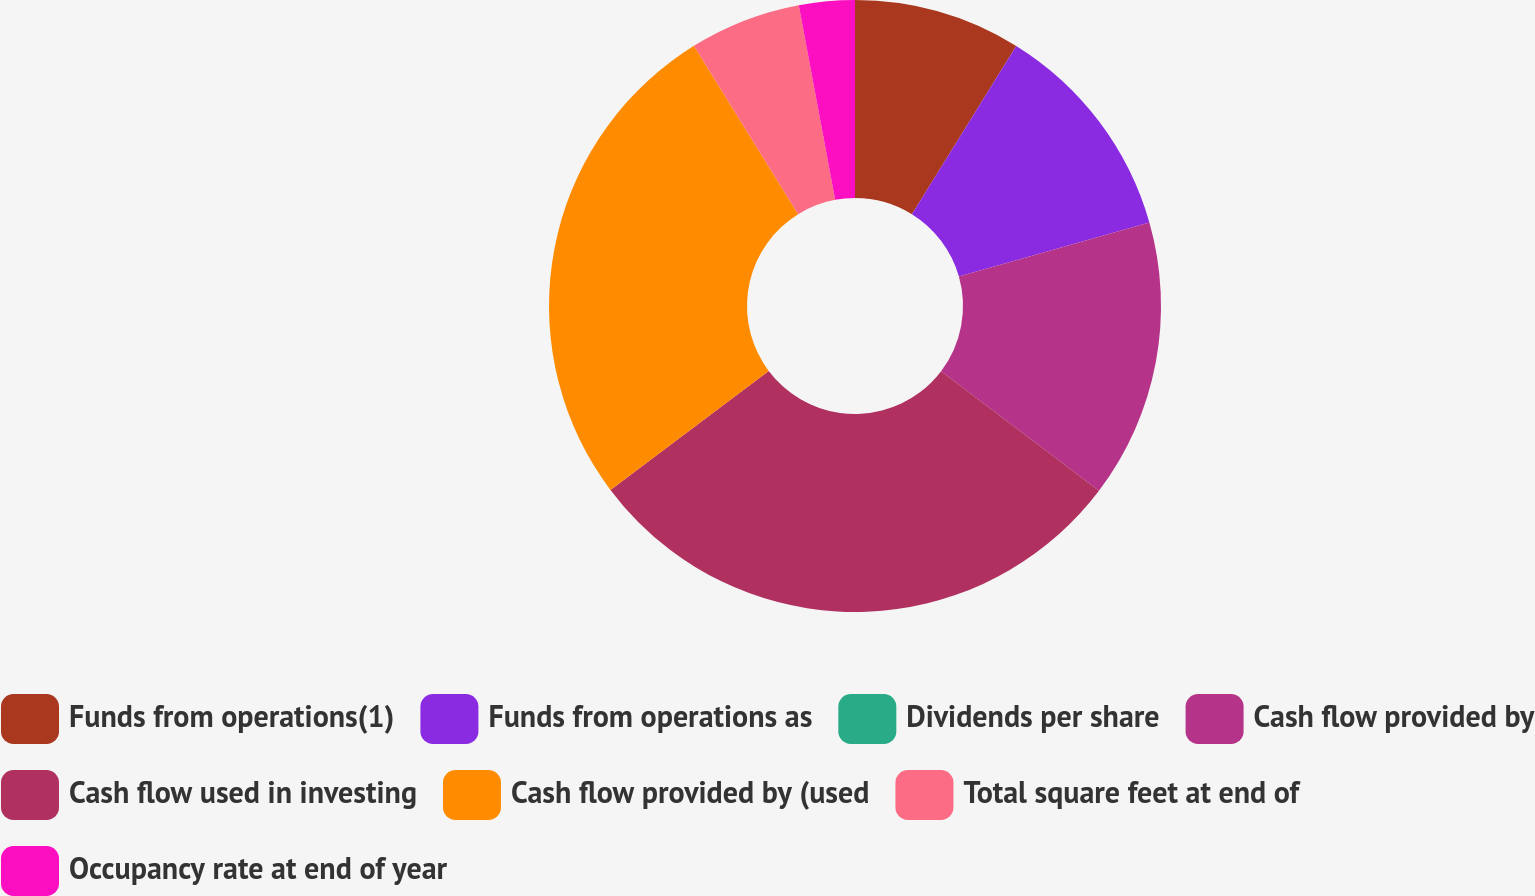<chart> <loc_0><loc_0><loc_500><loc_500><pie_chart><fcel>Funds from operations(1)<fcel>Funds from operations as<fcel>Dividends per share<fcel>Cash flow provided by<fcel>Cash flow used in investing<fcel>Cash flow provided by (used<fcel>Total square feet at end of<fcel>Occupancy rate at end of year<nl><fcel>8.83%<fcel>11.77%<fcel>0.0%<fcel>14.71%<fcel>29.42%<fcel>26.44%<fcel>5.88%<fcel>2.94%<nl></chart> 